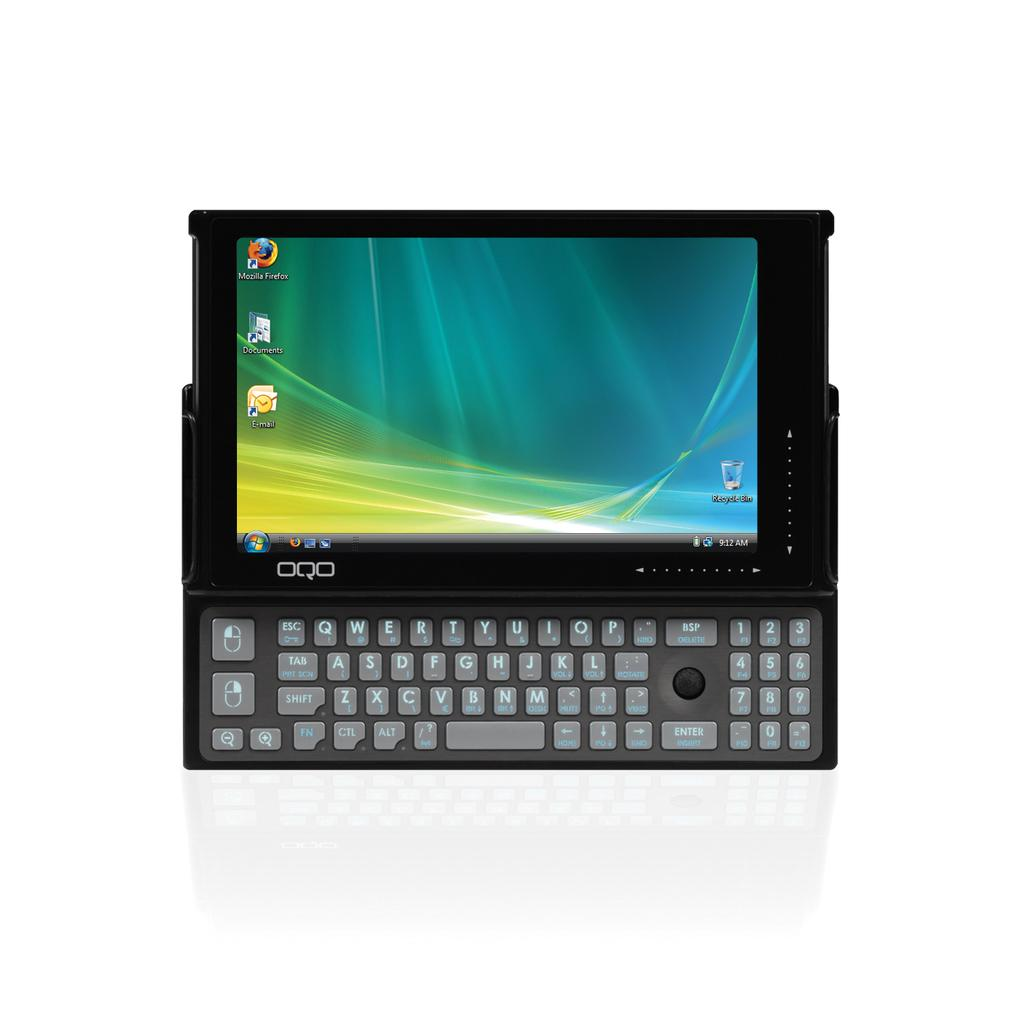Provide a one-sentence caption for the provided image. A tablet attached to a keyboard with Mozilla Firefox browser installed. 